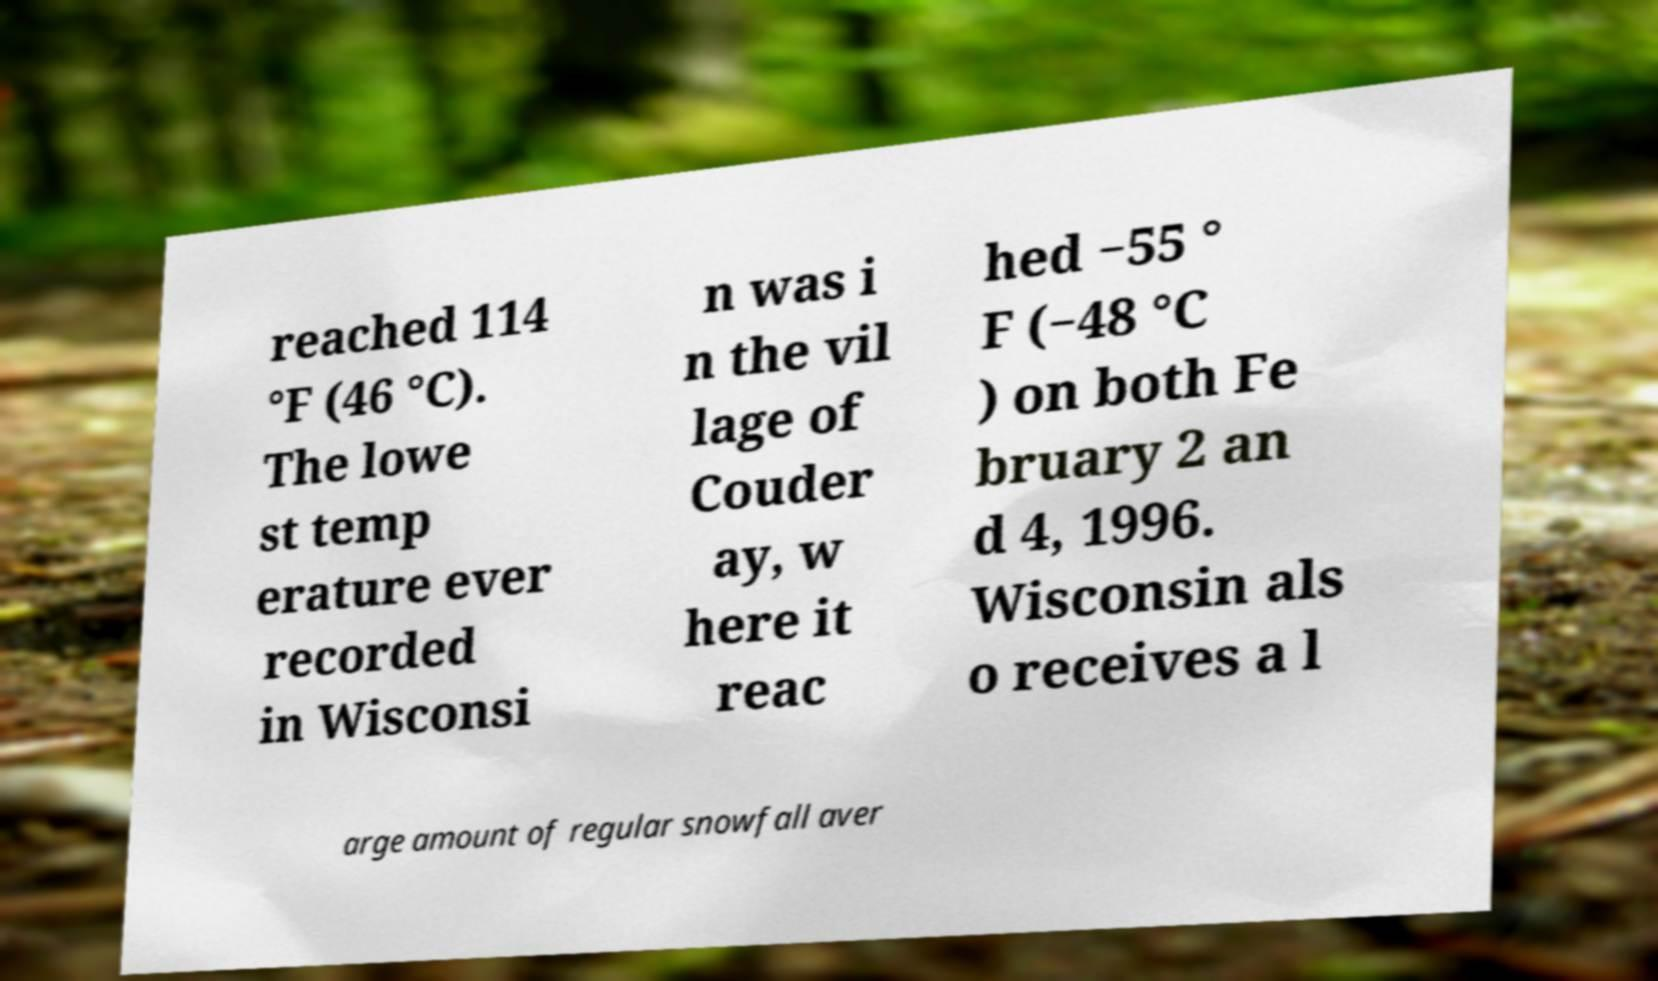What messages or text are displayed in this image? I need them in a readable, typed format. reached 114 °F (46 °C). The lowe st temp erature ever recorded in Wisconsi n was i n the vil lage of Couder ay, w here it reac hed −55 ° F (−48 °C ) on both Fe bruary 2 an d 4, 1996. Wisconsin als o receives a l arge amount of regular snowfall aver 